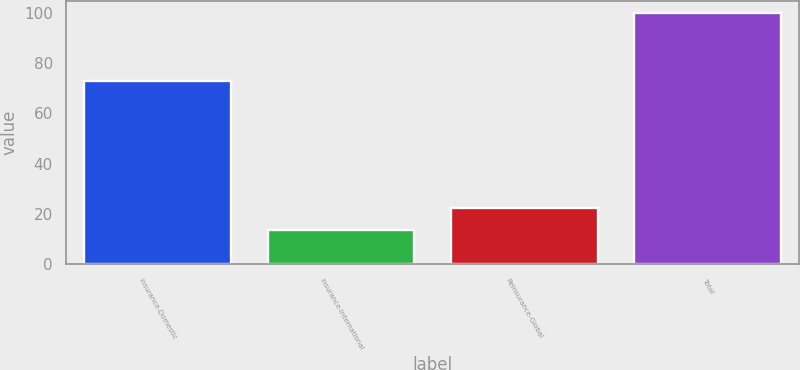<chart> <loc_0><loc_0><loc_500><loc_500><bar_chart><fcel>Insurance-Domestic<fcel>Insurance-International<fcel>Reinsurance-Global<fcel>Total<nl><fcel>72.8<fcel>13.6<fcel>22.24<fcel>100<nl></chart> 